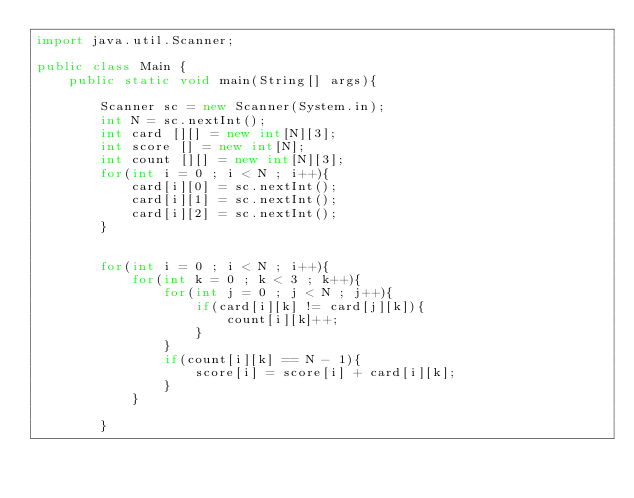Convert code to text. <code><loc_0><loc_0><loc_500><loc_500><_Java_>import java.util.Scanner;

public class Main {
	public static void main(String[] args){
		
		Scanner sc = new Scanner(System.in);
		int N = sc.nextInt();
		int card [][] = new int[N][3];
		int score [] = new int[N];
		int count [][] = new int[N][3];
		for(int i = 0 ; i < N ; i++){
			card[i][0] = sc.nextInt();
			card[i][1] = sc.nextInt();
			card[i][2] = sc.nextInt();
		}
		
		
		for(int i = 0 ; i < N ; i++){
			for(int k = 0 ; k < 3 ; k++){
				for(int j = 0 ; j < N ; j++){
					if(card[i][k] != card[j][k]){
						count[i][k]++;
					}
				}
				if(count[i][k] == N - 1){
					score[i] = score[i] + card[i][k];
				}
			}
			
		}</code> 